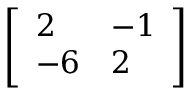Convert formula to latex. <formula><loc_0><loc_0><loc_500><loc_500>\left [ { \begin{array} { l l } { 2 } & { - 1 } \\ { - 6 } & { 2 } \end{array} } \right ]</formula> 